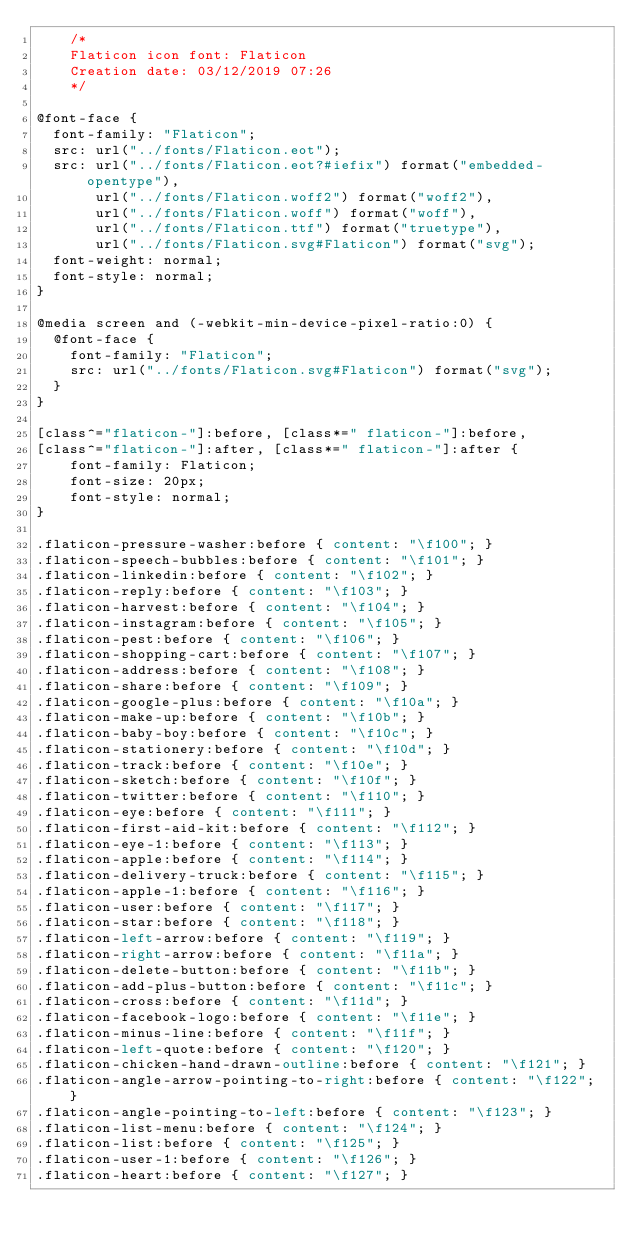<code> <loc_0><loc_0><loc_500><loc_500><_CSS_>	/*
  	Flaticon icon font: Flaticon
  	Creation date: 03/12/2019 07:26
  	*/

@font-face {
  font-family: "Flaticon";
  src: url("../fonts/Flaticon.eot");
  src: url("../fonts/Flaticon.eot?#iefix") format("embedded-opentype"),
       url("../fonts/Flaticon.woff2") format("woff2"),
       url("../fonts/Flaticon.woff") format("woff"),
       url("../fonts/Flaticon.ttf") format("truetype"),
       url("../fonts/Flaticon.svg#Flaticon") format("svg");
  font-weight: normal;
  font-style: normal;
}

@media screen and (-webkit-min-device-pixel-ratio:0) {
  @font-face {
    font-family: "Flaticon";
    src: url("../fonts/Flaticon.svg#Flaticon") format("svg");
  }
}

[class^="flaticon-"]:before, [class*=" flaticon-"]:before,
[class^="flaticon-"]:after, [class*=" flaticon-"]:after {   
    font-family: Flaticon;
    font-size: 20px;
    font-style: normal;
}

.flaticon-pressure-washer:before { content: "\f100"; }
.flaticon-speech-bubbles:before { content: "\f101"; }
.flaticon-linkedin:before { content: "\f102"; }
.flaticon-reply:before { content: "\f103"; }
.flaticon-harvest:before { content: "\f104"; }
.flaticon-instagram:before { content: "\f105"; }
.flaticon-pest:before { content: "\f106"; }
.flaticon-shopping-cart:before { content: "\f107"; }
.flaticon-address:before { content: "\f108"; }
.flaticon-share:before { content: "\f109"; }
.flaticon-google-plus:before { content: "\f10a"; }
.flaticon-make-up:before { content: "\f10b"; }
.flaticon-baby-boy:before { content: "\f10c"; }
.flaticon-stationery:before { content: "\f10d"; }
.flaticon-track:before { content: "\f10e"; }
.flaticon-sketch:before { content: "\f10f"; }
.flaticon-twitter:before { content: "\f110"; }
.flaticon-eye:before { content: "\f111"; }
.flaticon-first-aid-kit:before { content: "\f112"; }
.flaticon-eye-1:before { content: "\f113"; }
.flaticon-apple:before { content: "\f114"; }
.flaticon-delivery-truck:before { content: "\f115"; }
.flaticon-apple-1:before { content: "\f116"; }
.flaticon-user:before { content: "\f117"; }
.flaticon-star:before { content: "\f118"; }
.flaticon-left-arrow:before { content: "\f119"; }
.flaticon-right-arrow:before { content: "\f11a"; }
.flaticon-delete-button:before { content: "\f11b"; }
.flaticon-add-plus-button:before { content: "\f11c"; }
.flaticon-cross:before { content: "\f11d"; }
.flaticon-facebook-logo:before { content: "\f11e"; }
.flaticon-minus-line:before { content: "\f11f"; }
.flaticon-left-quote:before { content: "\f120"; }
.flaticon-chicken-hand-drawn-outline:before { content: "\f121"; }
.flaticon-angle-arrow-pointing-to-right:before { content: "\f122"; }
.flaticon-angle-pointing-to-left:before { content: "\f123"; }
.flaticon-list-menu:before { content: "\f124"; }
.flaticon-list:before { content: "\f125"; }
.flaticon-user-1:before { content: "\f126"; }
.flaticon-heart:before { content: "\f127"; }</code> 